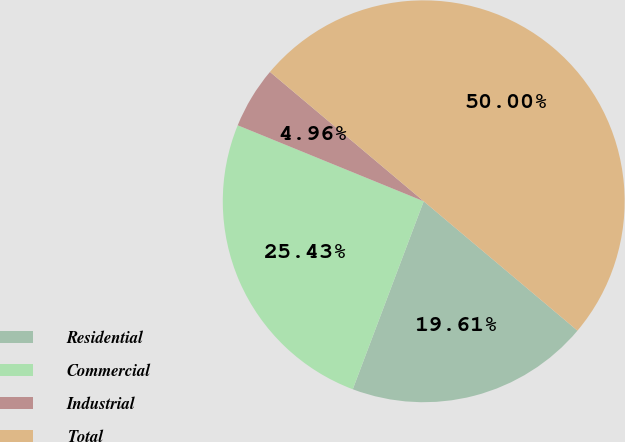Convert chart. <chart><loc_0><loc_0><loc_500><loc_500><pie_chart><fcel>Residential<fcel>Commercial<fcel>Industrial<fcel>Total<nl><fcel>19.61%<fcel>25.43%<fcel>4.96%<fcel>50.0%<nl></chart> 